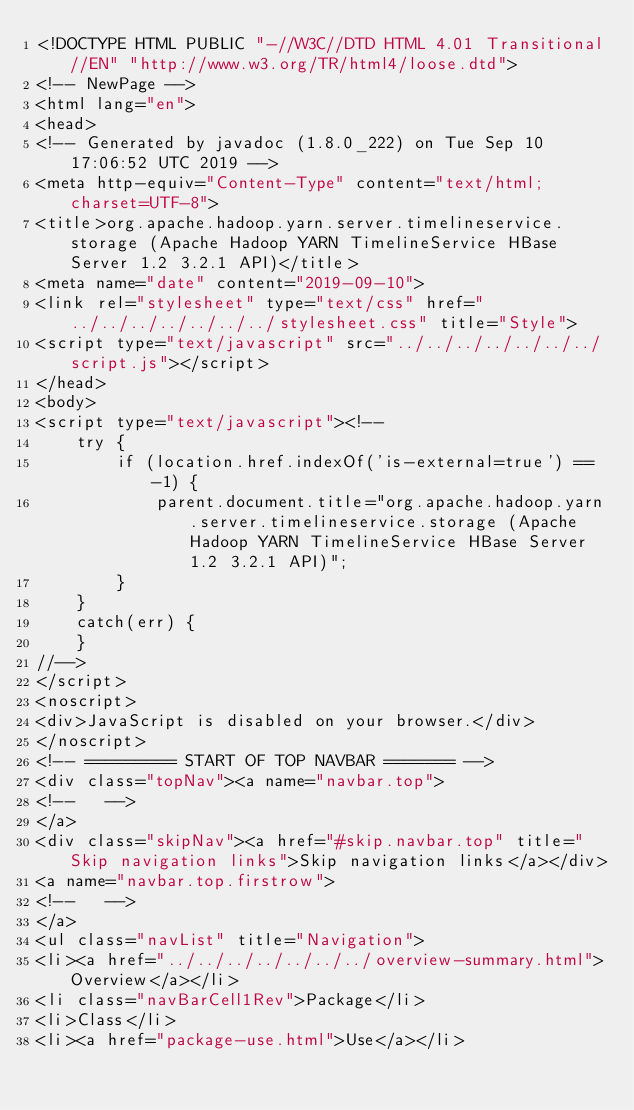Convert code to text. <code><loc_0><loc_0><loc_500><loc_500><_HTML_><!DOCTYPE HTML PUBLIC "-//W3C//DTD HTML 4.01 Transitional//EN" "http://www.w3.org/TR/html4/loose.dtd">
<!-- NewPage -->
<html lang="en">
<head>
<!-- Generated by javadoc (1.8.0_222) on Tue Sep 10 17:06:52 UTC 2019 -->
<meta http-equiv="Content-Type" content="text/html; charset=UTF-8">
<title>org.apache.hadoop.yarn.server.timelineservice.storage (Apache Hadoop YARN TimelineService HBase Server 1.2 3.2.1 API)</title>
<meta name="date" content="2019-09-10">
<link rel="stylesheet" type="text/css" href="../../../../../../../stylesheet.css" title="Style">
<script type="text/javascript" src="../../../../../../../script.js"></script>
</head>
<body>
<script type="text/javascript"><!--
    try {
        if (location.href.indexOf('is-external=true') == -1) {
            parent.document.title="org.apache.hadoop.yarn.server.timelineservice.storage (Apache Hadoop YARN TimelineService HBase Server 1.2 3.2.1 API)";
        }
    }
    catch(err) {
    }
//-->
</script>
<noscript>
<div>JavaScript is disabled on your browser.</div>
</noscript>
<!-- ========= START OF TOP NAVBAR ======= -->
<div class="topNav"><a name="navbar.top">
<!--   -->
</a>
<div class="skipNav"><a href="#skip.navbar.top" title="Skip navigation links">Skip navigation links</a></div>
<a name="navbar.top.firstrow">
<!--   -->
</a>
<ul class="navList" title="Navigation">
<li><a href="../../../../../../../overview-summary.html">Overview</a></li>
<li class="navBarCell1Rev">Package</li>
<li>Class</li>
<li><a href="package-use.html">Use</a></li></code> 